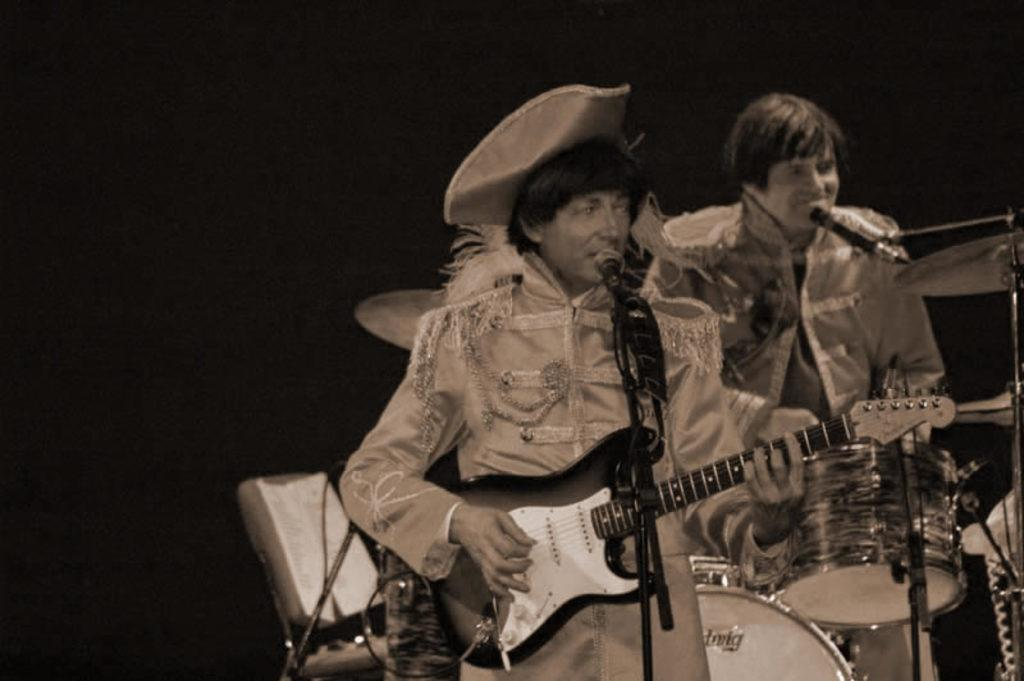What is the main activity being performed by the person in the foreground of the image? The person in the foreground of the image is playing guitar. What object is present near the person playing guitar? There is a microphone (mic) and a stand in the foreground of the image. What type of equipment is visible in the foreground of the image? There is a cable in the foreground of the image. What instrument is being played by the person in the background of the image? The person in the background of the image is playing drums. How would you describe the lighting in the top part of the image? The top part of the image is dark. How many family members are present in the image? The provided facts do not mention any family members, so it cannot be determined from the image. What type of body is visible in the image? There is no specific body mentioned in the image; it features people playing musical instruments. 